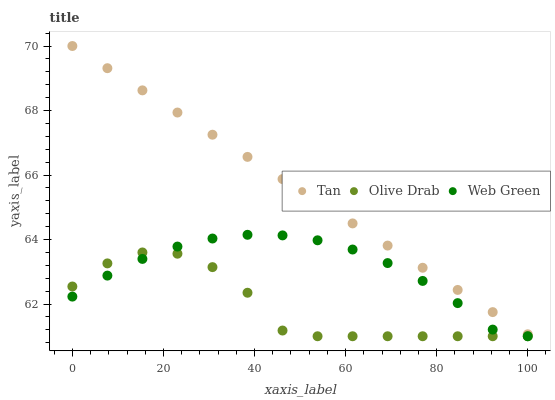Does Olive Drab have the minimum area under the curve?
Answer yes or no. Yes. Does Tan have the maximum area under the curve?
Answer yes or no. Yes. Does Web Green have the minimum area under the curve?
Answer yes or no. No. Does Web Green have the maximum area under the curve?
Answer yes or no. No. Is Tan the smoothest?
Answer yes or no. Yes. Is Olive Drab the roughest?
Answer yes or no. Yes. Is Web Green the smoothest?
Answer yes or no. No. Is Web Green the roughest?
Answer yes or no. No. Does Web Green have the lowest value?
Answer yes or no. Yes. Does Tan have the highest value?
Answer yes or no. Yes. Does Web Green have the highest value?
Answer yes or no. No. Is Olive Drab less than Tan?
Answer yes or no. Yes. Is Tan greater than Web Green?
Answer yes or no. Yes. Does Olive Drab intersect Web Green?
Answer yes or no. Yes. Is Olive Drab less than Web Green?
Answer yes or no. No. Is Olive Drab greater than Web Green?
Answer yes or no. No. Does Olive Drab intersect Tan?
Answer yes or no. No. 